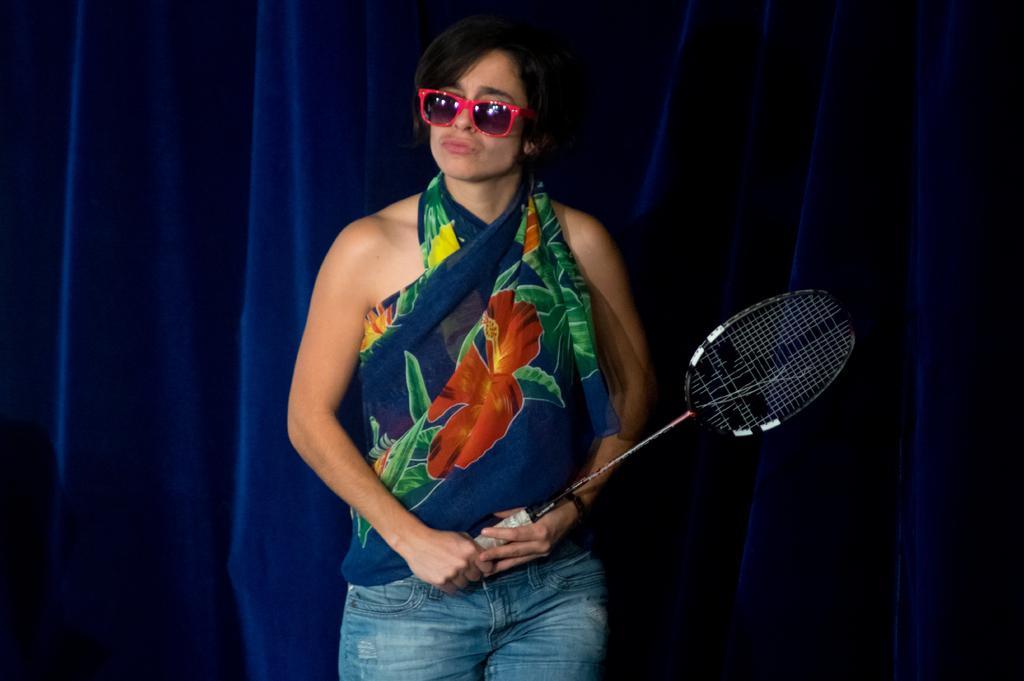Describe this image in one or two sentences. This picture shows a woman holding a badminton racket in her hand and she wore sunglasse on her face and we see curtain back of her 